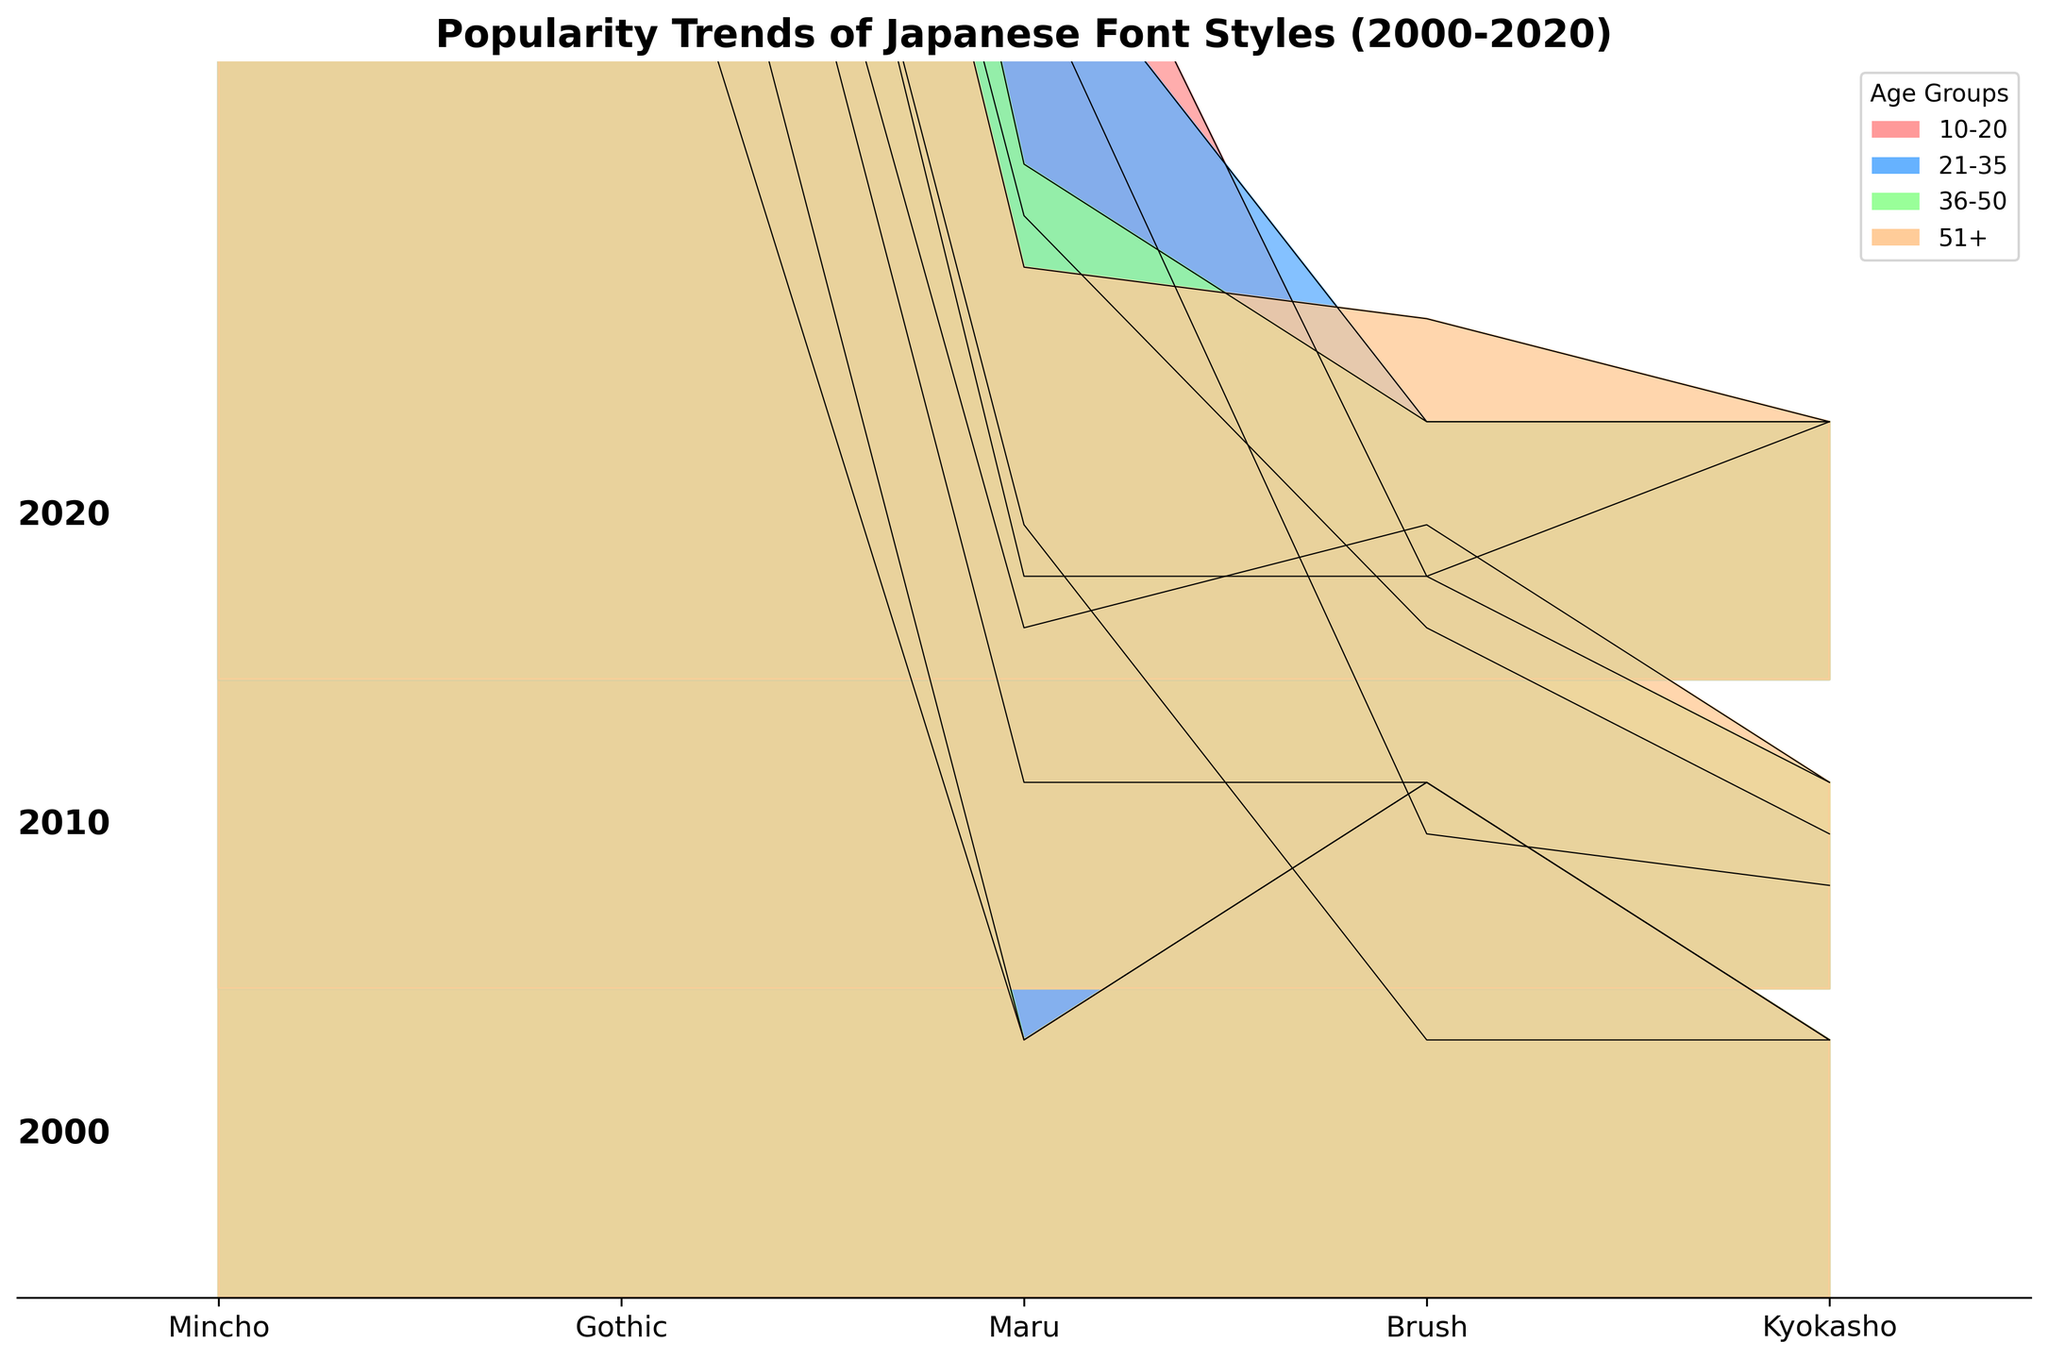what is the title of the figure? The title is prominently displayed at the top of the figure, stating the overall subject it represents.
Answer: Popularity Trends of Japanese Font Styles (2000-2020) Which font style was most popular among the 21-35 age group in 2020? From the section labeled 2020, we look at the data for the 21-35 age group. The highest filled region corresponds to the 'Gothic' font style.
Answer: Gothic How did the popularity of 'Mincho' change for the 10-20 age group from 2000 to 2020? We look at the heights of the 'Mincho' areas for the 10-20 age group in the years 2000 and 2020. In 2000 it was higher compared to 2020.
Answer: It decreased Compare the popularity of 'Brush' font in 2010 between the 10-20 and 51+ age groups. Check the heights for 'Brush' font in the respective age groups in the 2010 section. The 51+ age group is slightly higher than the 10-20 age group.
Answer: 51+ age group had higher 'Brush' popularity What trend do you notice for the 'Gothic' font style across all age groups from 2000 to 2020? By analyzing the height of the 'Gothic' regions across all age groups over the years, a general upward trend is visible.
Answer: Increasing trend Which age group showed the least interest in 'Maru' font style in 2000? In the 2000 section, observe the 'Maru' font style across all age groups and look for the smallest filled region. The 51+ age group had the least interest.
Answer: 51+ age group What is the combined popularity of 'Kyokasho' for the 36-50 age group in all years? Sum the heights of the 'Kyokasho' regions for the 36-50 age group in 2000, 2010, and 2020. The values are 5, 4, and 5 respectively, making the total (5 + 4 + 5) = 14.
Answer: 14 Is the 'Maru' font style more popular among the younger or older age groups in 2010? Compare the heights of the 'Maru' font style in the younger age groups (10-20, 21-35) to the older age groups (36-50, 51+) in 2010. The younger age groups have higher values.
Answer: Younger age groups How does the popularity spread of 'Gothic' in the 36-50 age group differ between 2000 and 2020? Compare the heights of the 'Gothic' font style for the 36-50 age group in 2000 and 2020. The popularity increased from 35 to 45.
Answer: It increased Which font style had the highest increase in popularity for the 10-20 age group from 2000 to 2010? Compare the changes in heights of all font styles for the 10-20 age group from 2000 to 2010. The largest increase is seen in the 'Gothic' font style, which rose from 45 to 50.
Answer: Gothic 